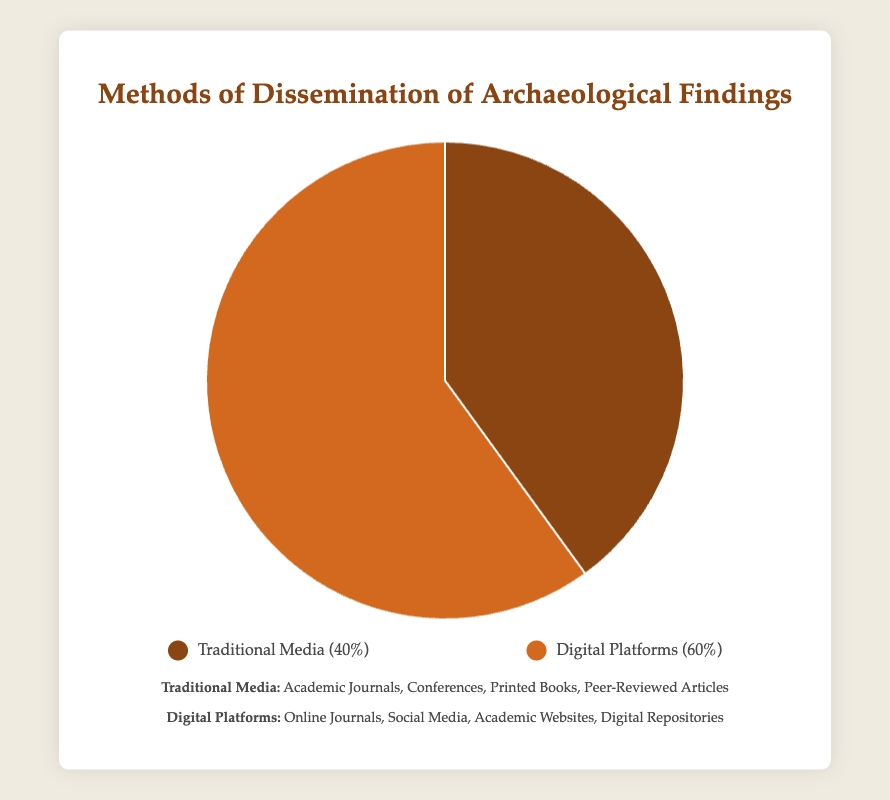What's the percentage of archaeological findings disseminated through traditional media? Referring to the pie chart, the segment labeled "Traditional Media" represents the dissemination through traditional channels. The chart indicates this portion as 40%.
Answer: 40% What's the percentage of archaeological findings disseminated through digital platforms? Referring to the pie chart, the segment labeled "Digital Platforms" represents the dissemination through digital means. The chart shows this portion as 60%.
Answer: 60% Which method is more frequently used for the dissemination of archaeological findings? By comparing the sizes of the pie chart segments, the "Digital Platforms" segment, which is 60%, is larger than the "Traditional Media" segment, which is 40%. Hence, digital platforms are more frequently used.
Answer: Digital Platforms What is the difference in percentage between the usage of digital platforms and traditional media for dissemination? To find the difference, subtract the percentage for traditional media (40%) from the percentage for digital platforms (60%). The difference is 60% - 40% = 20%.
Answer: 20% What is the combined percentage usage of both dissemination methods? Adding the percentages of both methods together, we have 40% (Traditional Media) + 60% (Digital Platforms) = 100%.
Answer: 100% If the chart were to be divided into degrees, how many degrees represent the traditional media segment? A full pie chart is 360 degrees. To find the degrees for traditional media, calculate (percentage of traditional media / 100) * 360. That is, (40 / 100) * 360 = 144 degrees.
Answer: 144 degrees What visual attribute distinguishes the traditional media segment from the digital platforms segment in the pie chart? The traditional media segment is colored in a certain shade distinct from the digital platforms segment. By recalling the legend, traditional media is brown.
Answer: Color Among the entities listed for both methods, which group comprises online journals? Referring to the entities listed under each dissemination method, "Online Journals" are mentioned under "Digital Platforms".
Answer: Digital Platforms How many entities are associated with traditional media and digital platforms combined? Counting the entities listed for both traditional media (4) and digital platforms (4), the total number of entities is 4 (Traditional Media) + 4 (Digital Platforms) = 8.
Answer: 8 